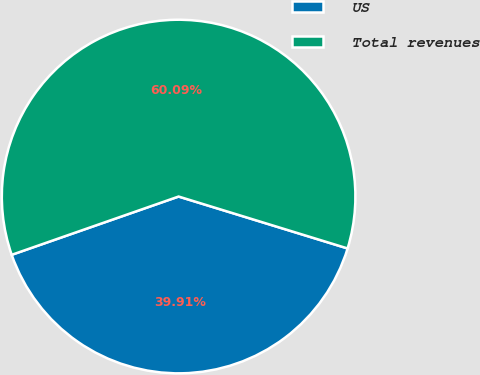Convert chart to OTSL. <chart><loc_0><loc_0><loc_500><loc_500><pie_chart><fcel>US<fcel>Total revenues<nl><fcel>39.91%<fcel>60.09%<nl></chart> 